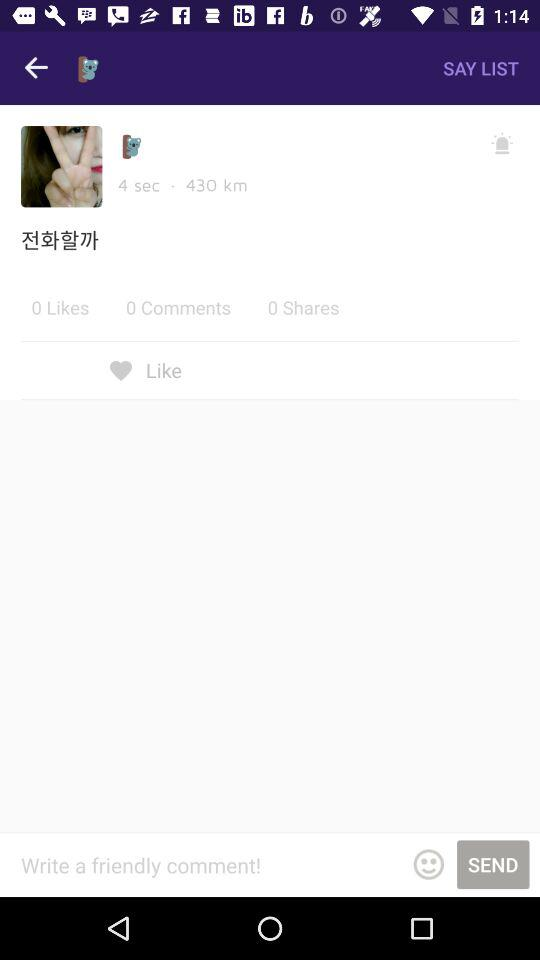How many more likes than shares are there?
Answer the question using a single word or phrase. 0 